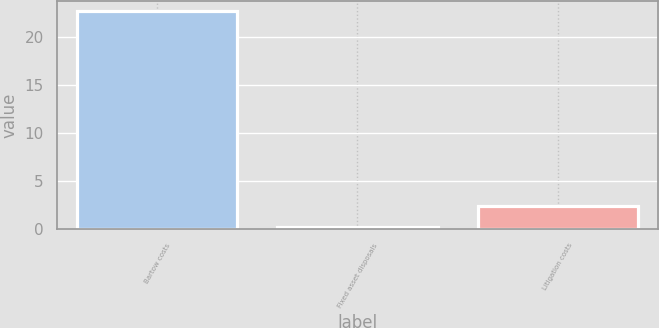Convert chart. <chart><loc_0><loc_0><loc_500><loc_500><bar_chart><fcel>Bartow costs<fcel>Fixed asset disposals<fcel>Litigation costs<nl><fcel>22.6<fcel>0.2<fcel>2.44<nl></chart> 